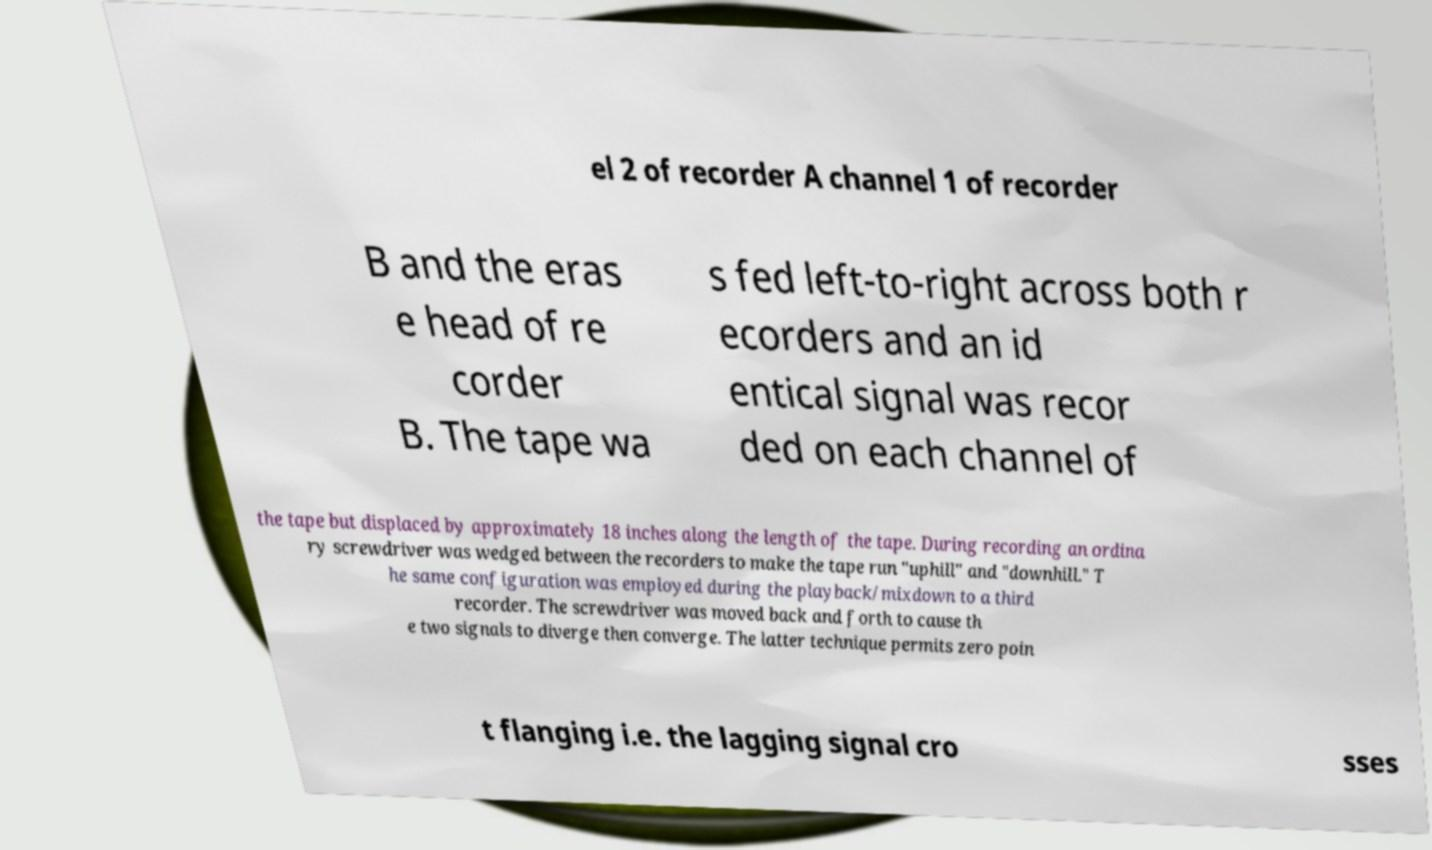What messages or text are displayed in this image? I need them in a readable, typed format. el 2 of recorder A channel 1 of recorder B and the eras e head of re corder B. The tape wa s fed left-to-right across both r ecorders and an id entical signal was recor ded on each channel of the tape but displaced by approximately 18 inches along the length of the tape. During recording an ordina ry screwdriver was wedged between the recorders to make the tape run "uphill" and "downhill." T he same configuration was employed during the playback/mixdown to a third recorder. The screwdriver was moved back and forth to cause th e two signals to diverge then converge. The latter technique permits zero poin t flanging i.e. the lagging signal cro sses 